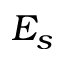Convert formula to latex. <formula><loc_0><loc_0><loc_500><loc_500>E _ { s }</formula> 